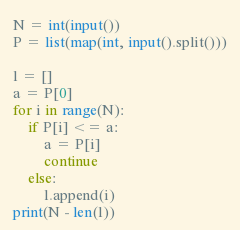Convert code to text. <code><loc_0><loc_0><loc_500><loc_500><_Python_>N = int(input())
P = list(map(int, input().split()))

l = []
a = P[0]
for i in range(N):
    if P[i] <= a:
        a = P[i]
        continue
    else:
        l.append(i)
print(N - len(l))</code> 